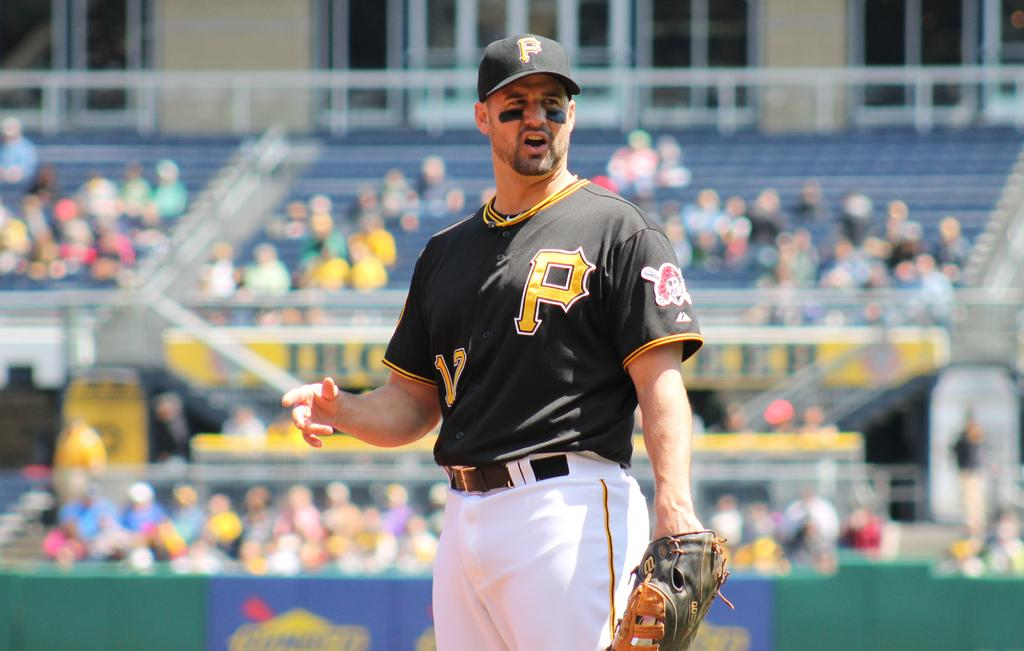<image>
Write a terse but informative summary of the picture. Baseball Player with a yellow P on left side of jersey. 